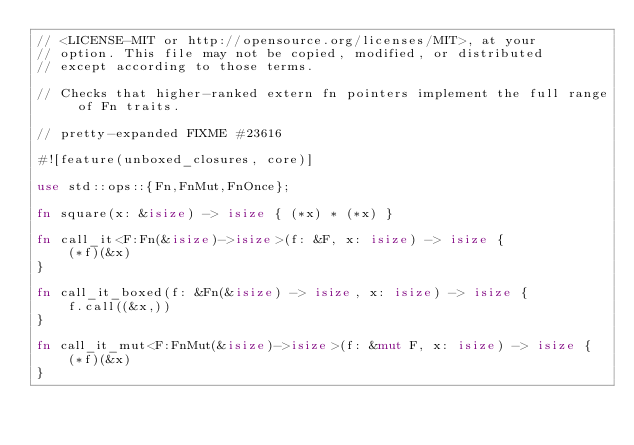<code> <loc_0><loc_0><loc_500><loc_500><_Rust_>// <LICENSE-MIT or http://opensource.org/licenses/MIT>, at your
// option. This file may not be copied, modified, or distributed
// except according to those terms.

// Checks that higher-ranked extern fn pointers implement the full range of Fn traits.

// pretty-expanded FIXME #23616

#![feature(unboxed_closures, core)]

use std::ops::{Fn,FnMut,FnOnce};

fn square(x: &isize) -> isize { (*x) * (*x) }

fn call_it<F:Fn(&isize)->isize>(f: &F, x: isize) -> isize {
    (*f)(&x)
}

fn call_it_boxed(f: &Fn(&isize) -> isize, x: isize) -> isize {
    f.call((&x,))
}

fn call_it_mut<F:FnMut(&isize)->isize>(f: &mut F, x: isize) -> isize {
    (*f)(&x)
}
</code> 